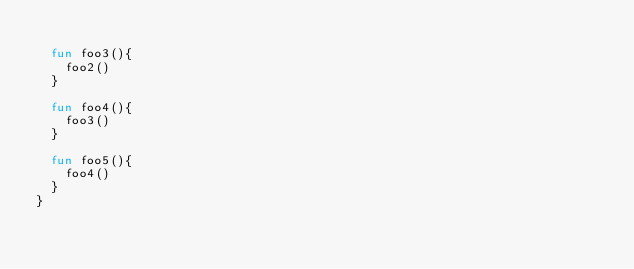Convert code to text. <code><loc_0><loc_0><loc_500><loc_500><_Kotlin_>
  fun foo3(){
    foo2()
  }

  fun foo4(){
    foo3()
  }

  fun foo5(){
    foo4()
  }
}</code> 